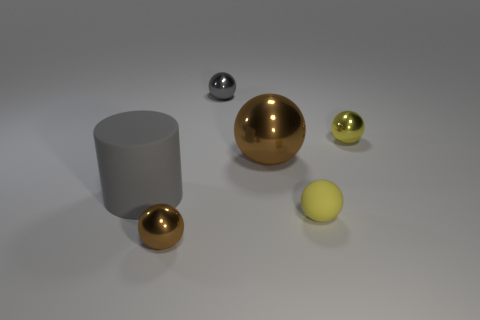Subtract 2 balls. How many balls are left? 3 Subtract all purple spheres. Subtract all brown cubes. How many spheres are left? 5 Add 2 brown blocks. How many objects exist? 8 Subtract all cylinders. How many objects are left? 5 Subtract all yellow matte objects. Subtract all big brown objects. How many objects are left? 4 Add 1 tiny brown things. How many tiny brown things are left? 2 Add 6 small cyan matte balls. How many small cyan matte balls exist? 6 Subtract 0 cyan blocks. How many objects are left? 6 